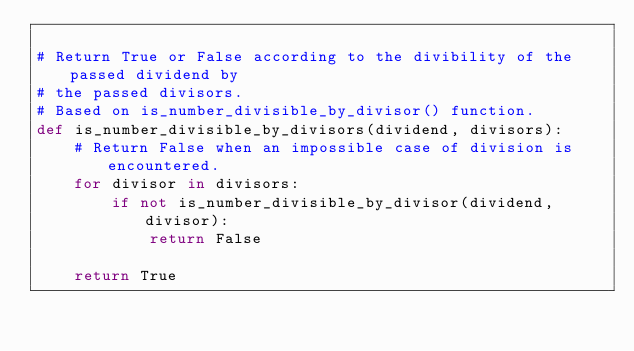Convert code to text. <code><loc_0><loc_0><loc_500><loc_500><_Python_>
# Return True or False according to the divibility of the passed dividend by
# the passed divisors.
# Based on is_number_divisible_by_divisor() function.
def is_number_divisible_by_divisors(dividend, divisors):
    # Return False when an impossible case of division is encountered.
    for divisor in divisors:
        if not is_number_divisible_by_divisor(dividend, divisor):
            return False
    
    return True</code> 